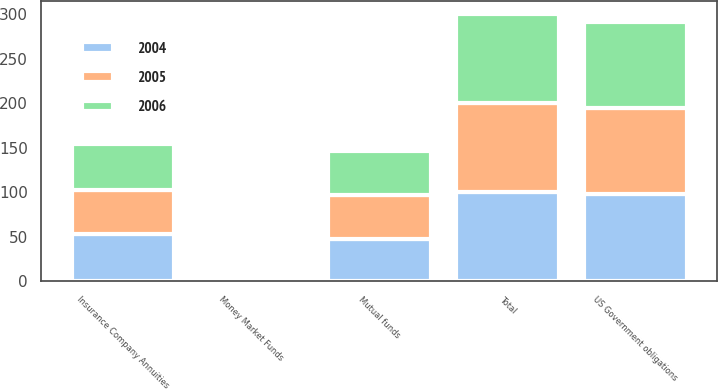Convert chart to OTSL. <chart><loc_0><loc_0><loc_500><loc_500><stacked_bar_chart><ecel><fcel>US Government obligations<fcel>Money Market Funds<fcel>Total<fcel>Mutual funds<fcel>Insurance Company Annuities<nl><fcel>2004<fcel>98<fcel>2<fcel>100<fcel>47<fcel>53<nl><fcel>2006<fcel>96<fcel>4<fcel>100<fcel>49<fcel>51<nl><fcel>2005<fcel>97<fcel>3<fcel>100<fcel>50<fcel>50<nl></chart> 